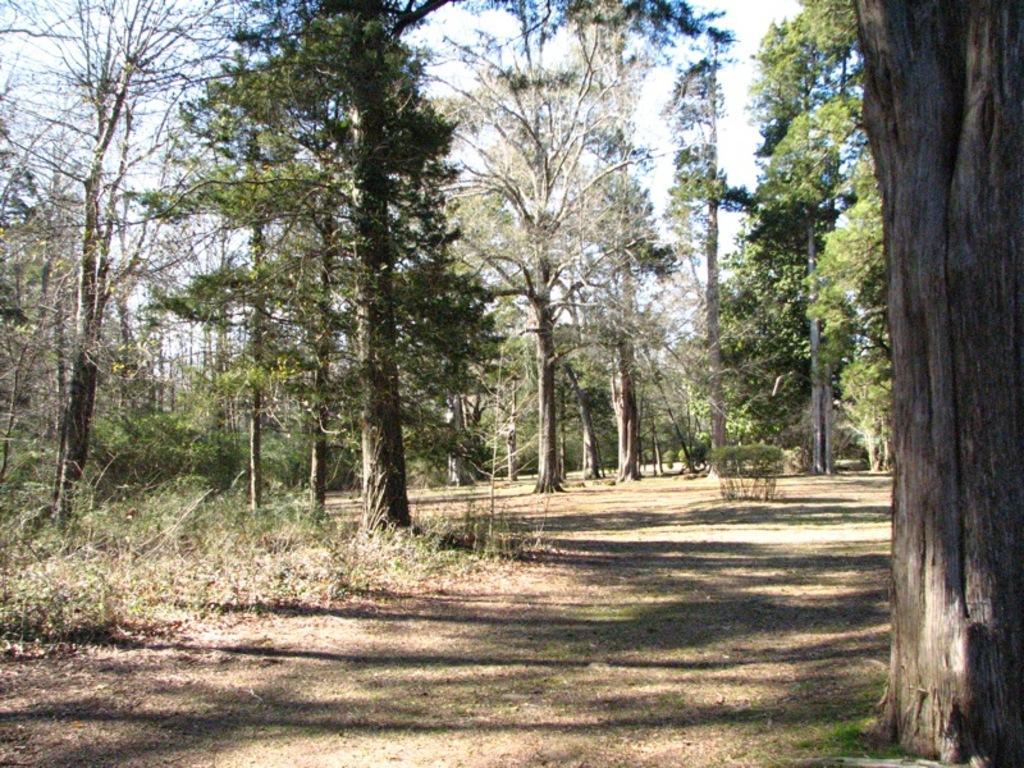Please provide a concise description of this image. In this image there is ground at the bottom. There is a bark, there are trees on the right corner. There are trees on the left and in the background. There is sky at the top. 